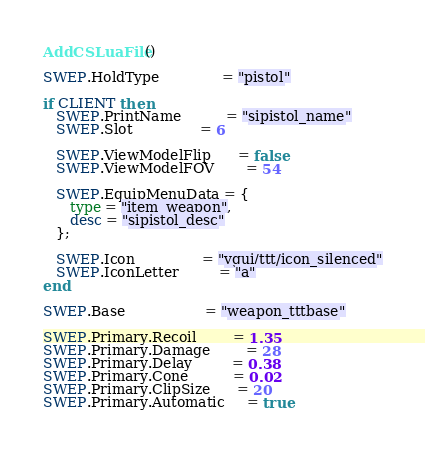<code> <loc_0><loc_0><loc_500><loc_500><_Lua_>AddCSLuaFile()

SWEP.HoldType              = "pistol"

if CLIENT then
   SWEP.PrintName          = "sipistol_name"
   SWEP.Slot               = 6

   SWEP.ViewModelFlip      = false
   SWEP.ViewModelFOV       = 54

   SWEP.EquipMenuData = {
      type = "item_weapon",
      desc = "sipistol_desc"
   };

   SWEP.Icon               = "vgui/ttt/icon_silenced"
   SWEP.IconLetter         = "a"
end

SWEP.Base                  = "weapon_tttbase"

SWEP.Primary.Recoil        = 1.35
SWEP.Primary.Damage        = 28
SWEP.Primary.Delay         = 0.38
SWEP.Primary.Cone          = 0.02
SWEP.Primary.ClipSize      = 20
SWEP.Primary.Automatic     = true</code> 